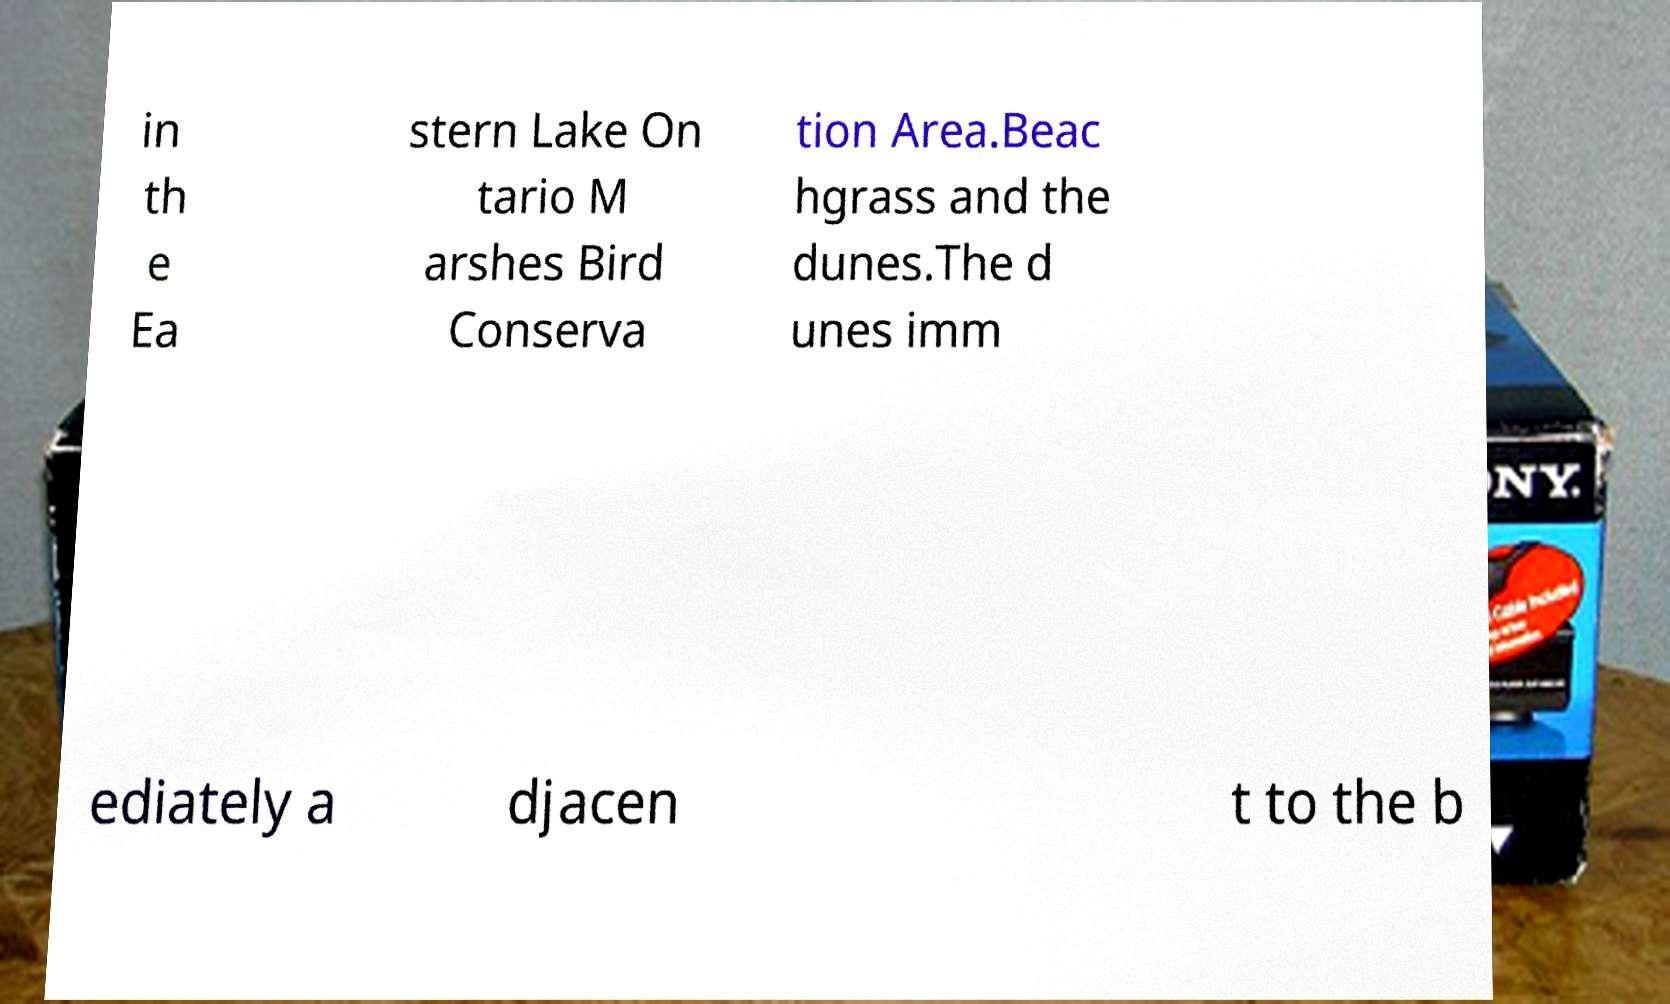Could you assist in decoding the text presented in this image and type it out clearly? in th e Ea stern Lake On tario M arshes Bird Conserva tion Area.Beac hgrass and the dunes.The d unes imm ediately a djacen t to the b 